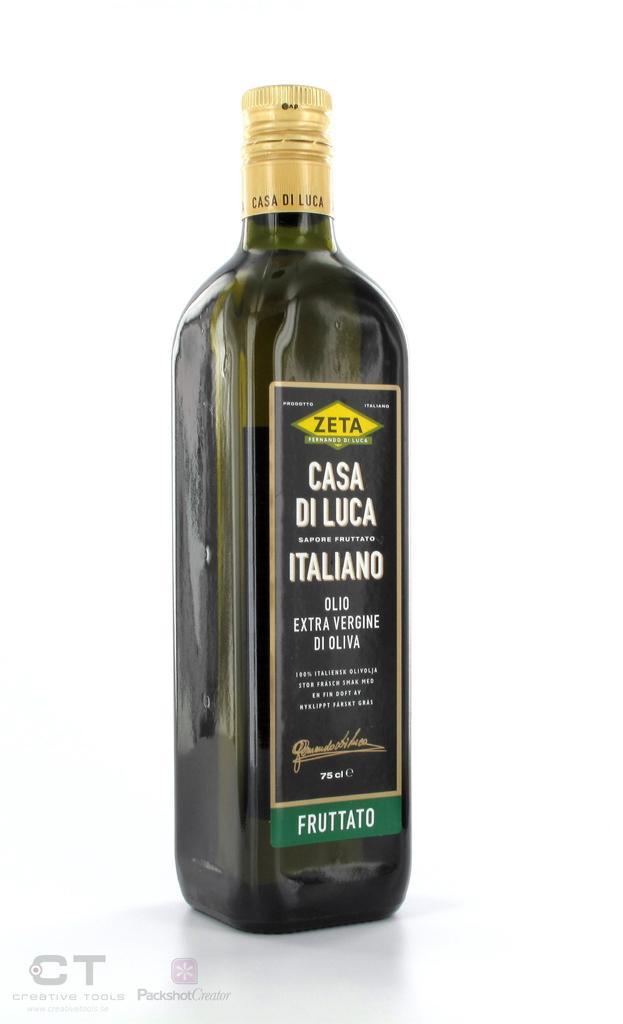In one or two sentences, can you explain what this image depicts? In this image, we can see a bottle on the white background. There is a label on the bottle contains some text. 